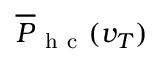Convert formula to latex. <formula><loc_0><loc_0><loc_500><loc_500>\overline { P } _ { h c } ( v _ { T } )</formula> 